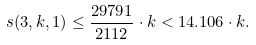<formula> <loc_0><loc_0><loc_500><loc_500>s ( 3 , k , 1 ) \leq \frac { 2 9 7 9 1 } { 2 1 1 2 } \cdot k < 1 4 . 1 0 6 \cdot k .</formula> 